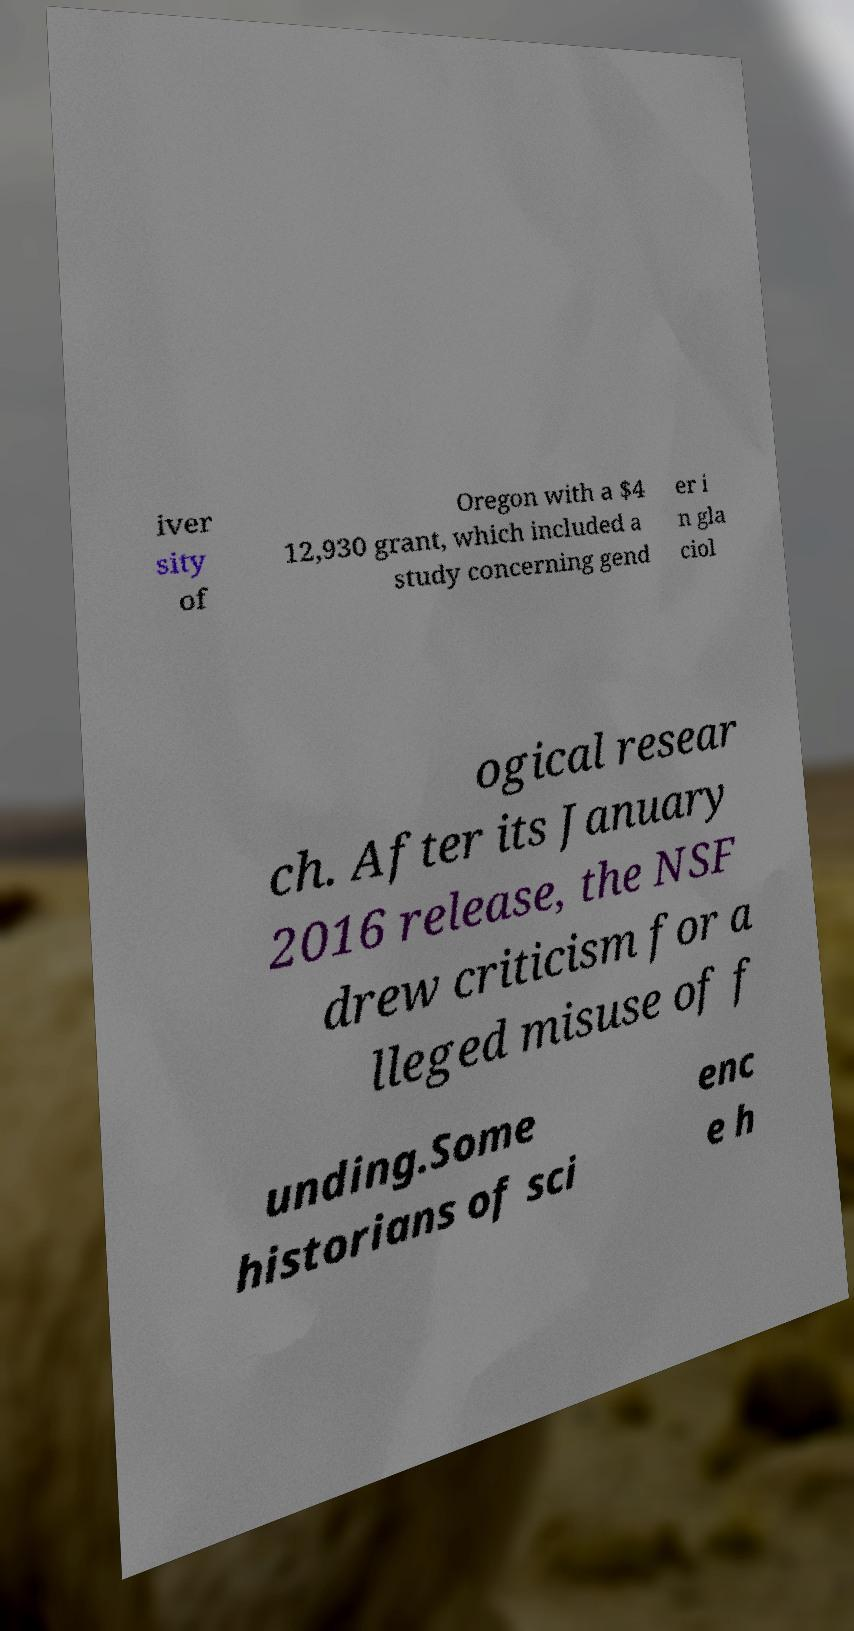I need the written content from this picture converted into text. Can you do that? iver sity of Oregon with a $4 12,930 grant, which included a study concerning gend er i n gla ciol ogical resear ch. After its January 2016 release, the NSF drew criticism for a lleged misuse of f unding.Some historians of sci enc e h 